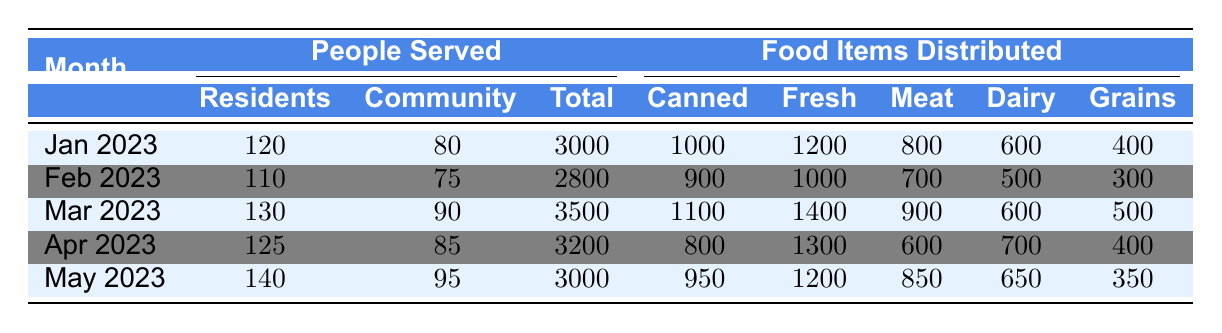What was the total number of residents served in March 2023? The table shows that in March 2023, the number of residents served is listed under the "Residents" column. From the table, it can be directly read as 130.
Answer: 130 What type of food item was distributed the most in January 2023? By looking at the January 2023 row, we compare the values in the type_of_food sub-category. The highest value is for fresh produce at 1200 items.
Answer: Fresh produce What is the total number of people (residents and community members) served in February 2023? To find the total, we add the number of residents (110) and community members (75) served in February 2023. The sum is 110 + 75 = 185.
Answer: 185 In which month did the shelter distribute the least amount of food items? By comparing the "Food Items Distributed" column across all months, the lowest value appears in February 2023, which is 2800 items.
Answer: February 2023 What was the average number of food items distributed per month from January to May 2023? To find the average, we sum the total food items distributed across the five months: 3000 + 2800 + 3500 + 3200 + 3000 = 15500. Then, we divide this total by 5 (the number of months): 15500 / 5 = 3100.
Answer: 3100 Is it true that more community members were served in May than in January? To verify this, we check the number of community members served in both months. In May, it was 95, while in January it was 80. Since 95 is greater than 80, the statement is true.
Answer: Yes Which month saw the highest distribution of canned goods? Looking through the "Canned" column, the maximum value is 1100 items in March 2023, which indicates that this month had the highest canned goods distribution.
Answer: March 2023 What was the difference in total food items distributed between April and March 2023? We subtract the total food items distributed in April (3200) from that in March (3500): 3500 - 3200 = 300.
Answer: 300 How many more residents were served in May compared to February 2023? By comparing the resident numbers, in May it was 140 and in February it was 110. The difference is 140 - 110 = 30, indicating that 30 more residents were served in May.
Answer: 30 